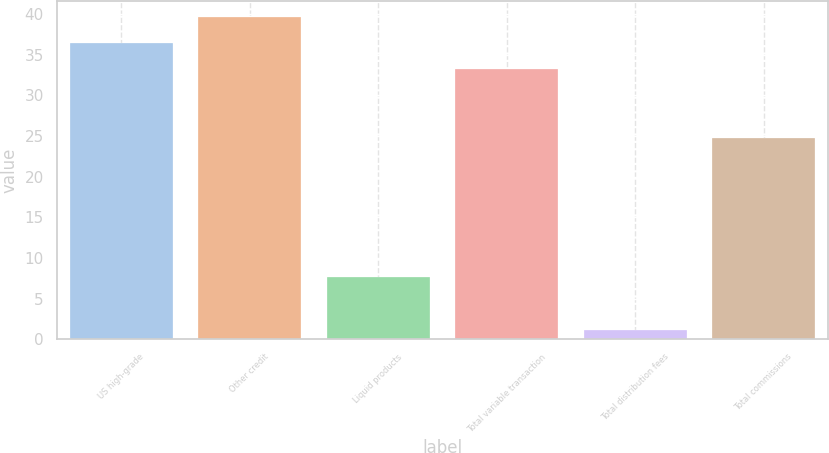Convert chart to OTSL. <chart><loc_0><loc_0><loc_500><loc_500><bar_chart><fcel>US high-grade<fcel>Other credit<fcel>Liquid products<fcel>Total variable transaction<fcel>Total distribution fees<fcel>Total commissions<nl><fcel>36.45<fcel>39.7<fcel>7.7<fcel>33.2<fcel>1.1<fcel>24.8<nl></chart> 